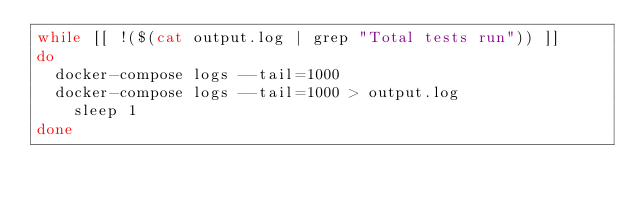<code> <loc_0><loc_0><loc_500><loc_500><_Bash_>while [[ !($(cat output.log | grep "Total tests run")) ]]
do
	docker-compose logs --tail=1000
	docker-compose logs --tail=1000 > output.log
    sleep 1
done
</code> 